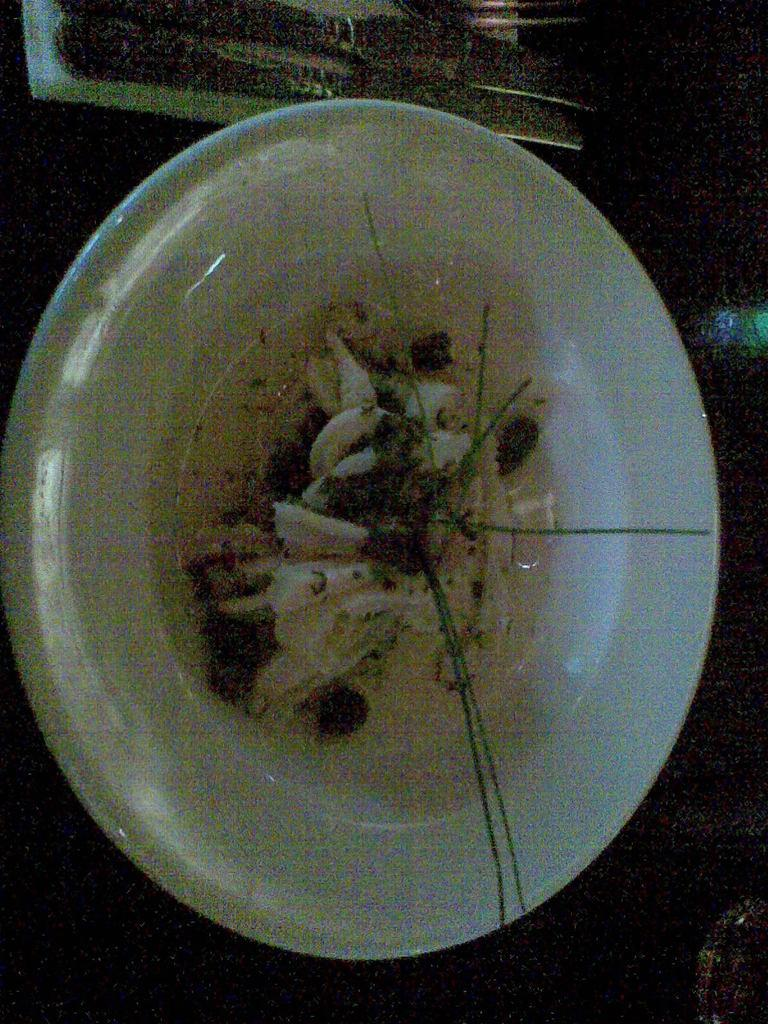What is present on the table in the image? There is a plate, spoons, a fork, and food on the table in the image. What type of utensils can be seen in the image? Spoons and a fork are visible in the image. What might be used to eat the food on the table? The spoons and fork can be used to eat the food on the table. What invention is being taught at the school in the image? There is no school or invention present in the image; it only features a plate, spoons, a fork, and food on a table. Can you describe the ant that is crawling on the food in the image? There is no ant present in the image; it only features a plate, spoons, a fork, and food on a table. 